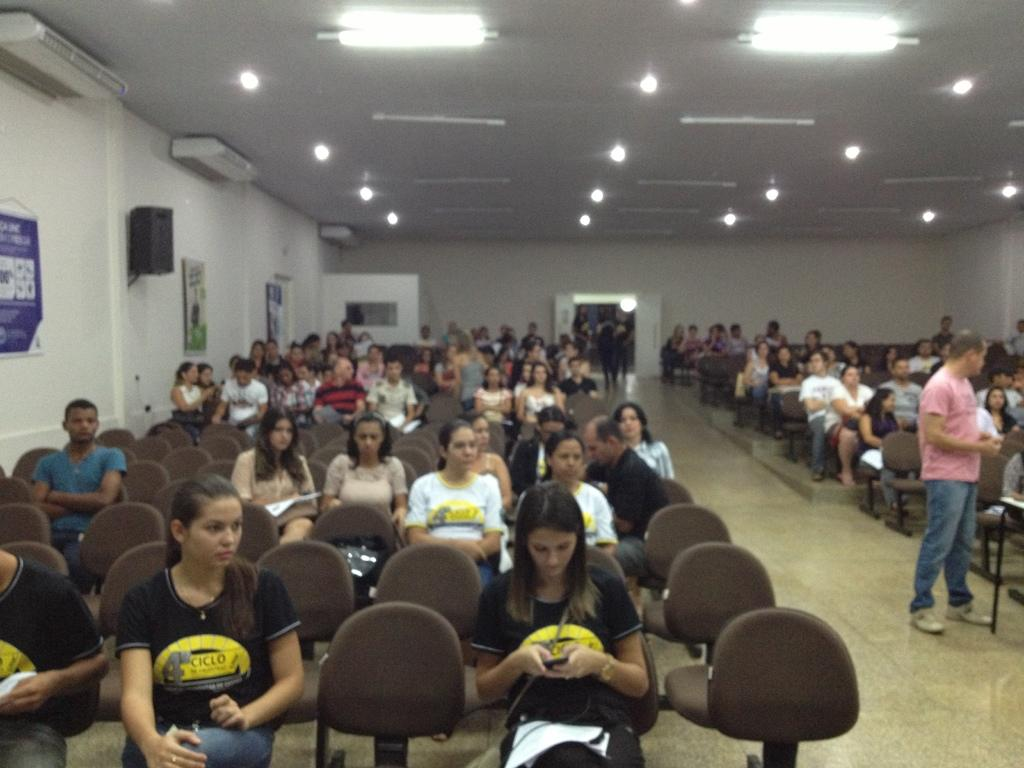What are the people in the image doing? There are people sitting on chairs and standing in the image. Can you describe the lighting in the image? There are lights attached to the roof in the image. What type of cent can be seen in the image? There is no cent present in the image. Is there a tent visible in the image? There is no tent present in the image. 